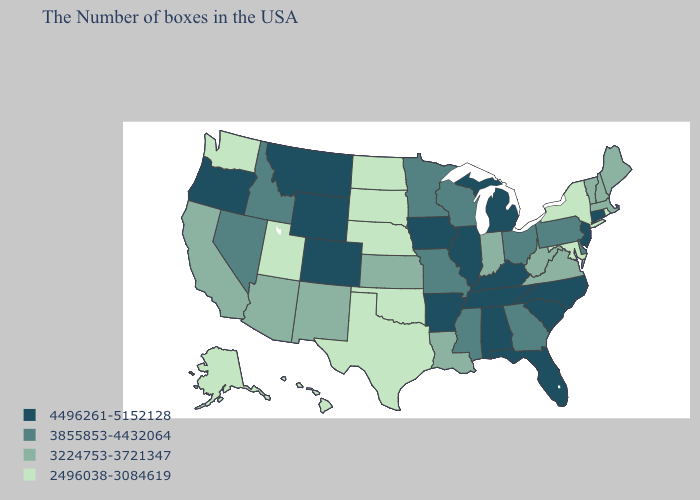What is the value of Indiana?
Be succinct. 3224753-3721347. Among the states that border Minnesota , does South Dakota have the highest value?
Write a very short answer. No. Among the states that border California , which have the lowest value?
Write a very short answer. Arizona. Among the states that border New York , does Massachusetts have the lowest value?
Answer briefly. Yes. What is the value of Rhode Island?
Give a very brief answer. 2496038-3084619. Name the states that have a value in the range 3224753-3721347?
Give a very brief answer. Maine, Massachusetts, New Hampshire, Vermont, Virginia, West Virginia, Indiana, Louisiana, Kansas, New Mexico, Arizona, California. Among the states that border Washington , which have the highest value?
Be succinct. Oregon. Does New Jersey have the highest value in the Northeast?
Quick response, please. Yes. Is the legend a continuous bar?
Keep it brief. No. Does Alaska have the lowest value in the USA?
Give a very brief answer. Yes. Does the first symbol in the legend represent the smallest category?
Short answer required. No. What is the value of South Dakota?
Concise answer only. 2496038-3084619. What is the lowest value in the USA?
Write a very short answer. 2496038-3084619. Name the states that have a value in the range 3224753-3721347?
Keep it brief. Maine, Massachusetts, New Hampshire, Vermont, Virginia, West Virginia, Indiana, Louisiana, Kansas, New Mexico, Arizona, California. Name the states that have a value in the range 4496261-5152128?
Quick response, please. Connecticut, New Jersey, North Carolina, South Carolina, Florida, Michigan, Kentucky, Alabama, Tennessee, Illinois, Arkansas, Iowa, Wyoming, Colorado, Montana, Oregon. 